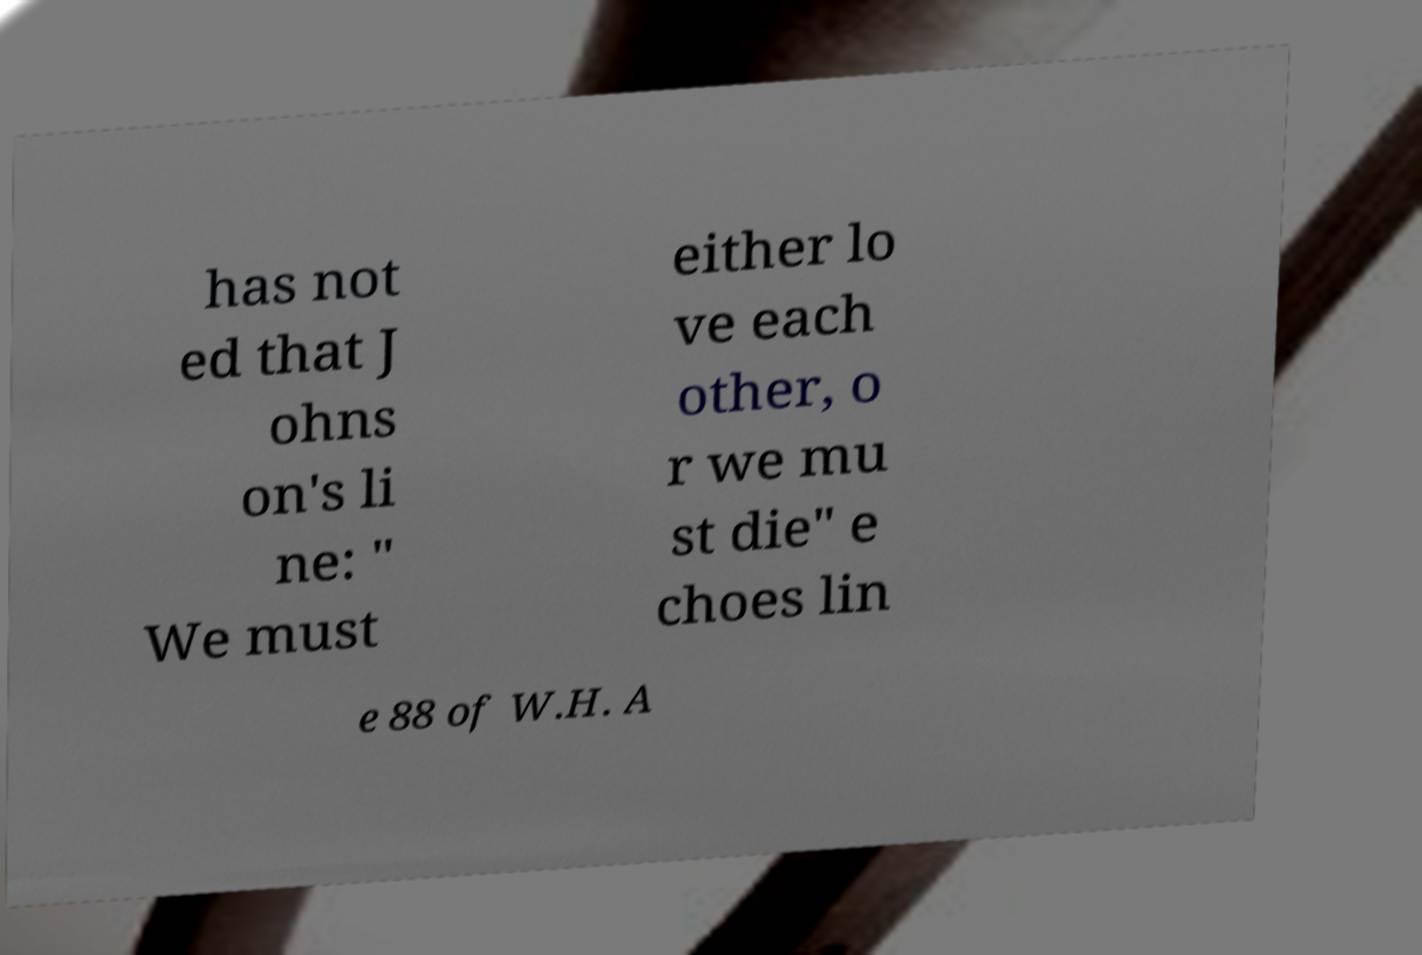There's text embedded in this image that I need extracted. Can you transcribe it verbatim? has not ed that J ohns on's li ne: " We must either lo ve each other, o r we mu st die" e choes lin e 88 of W.H. A 